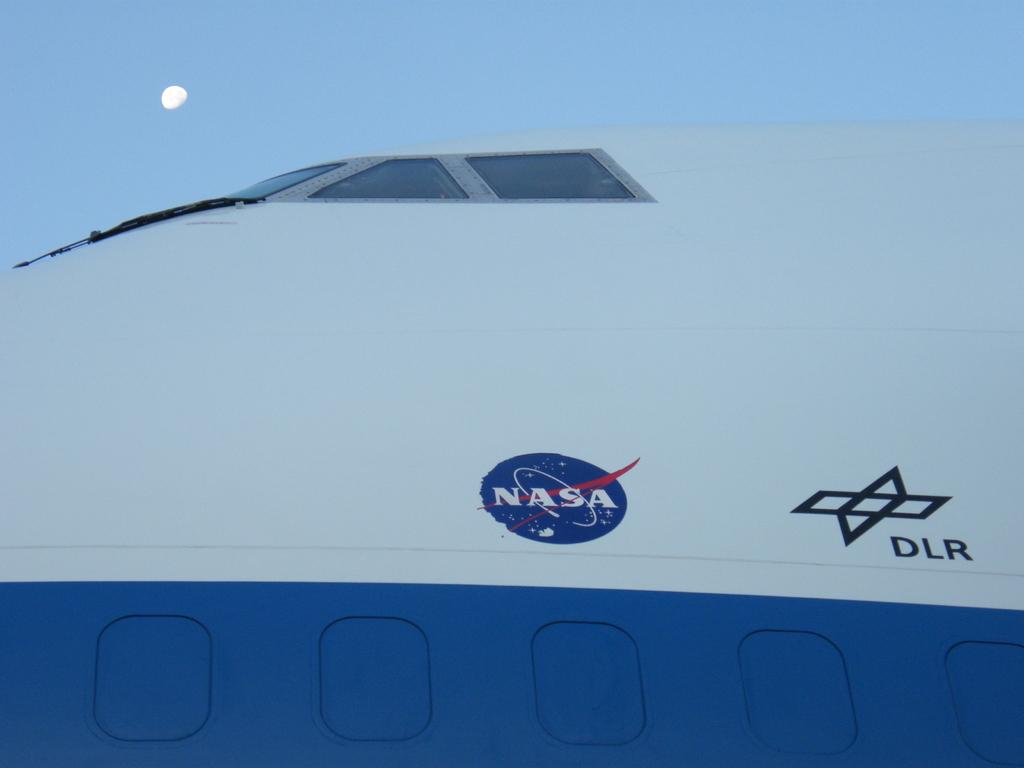Where is this aircraft located?
Provide a succinct answer. Nasa. Which organization operates this vehicle?
Offer a terse response. Nasa. 